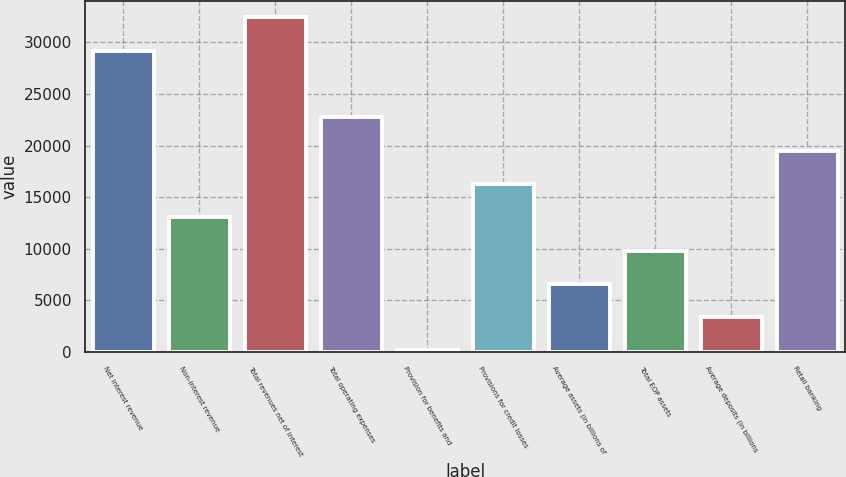Convert chart. <chart><loc_0><loc_0><loc_500><loc_500><bar_chart><fcel>Net interest revenue<fcel>Non-interest revenue<fcel>Total revenues net of interest<fcel>Total operating expenses<fcel>Provision for benefits and<fcel>Provisions for credit losses<fcel>Average assets (in billions of<fcel>Total EOP assets<fcel>Average deposits (in billions<fcel>Retail banking<nl><fcel>29212.9<fcel>13067.4<fcel>32442<fcel>22754.7<fcel>151<fcel>16296.5<fcel>6609.2<fcel>9838.3<fcel>3380.1<fcel>19525.6<nl></chart> 